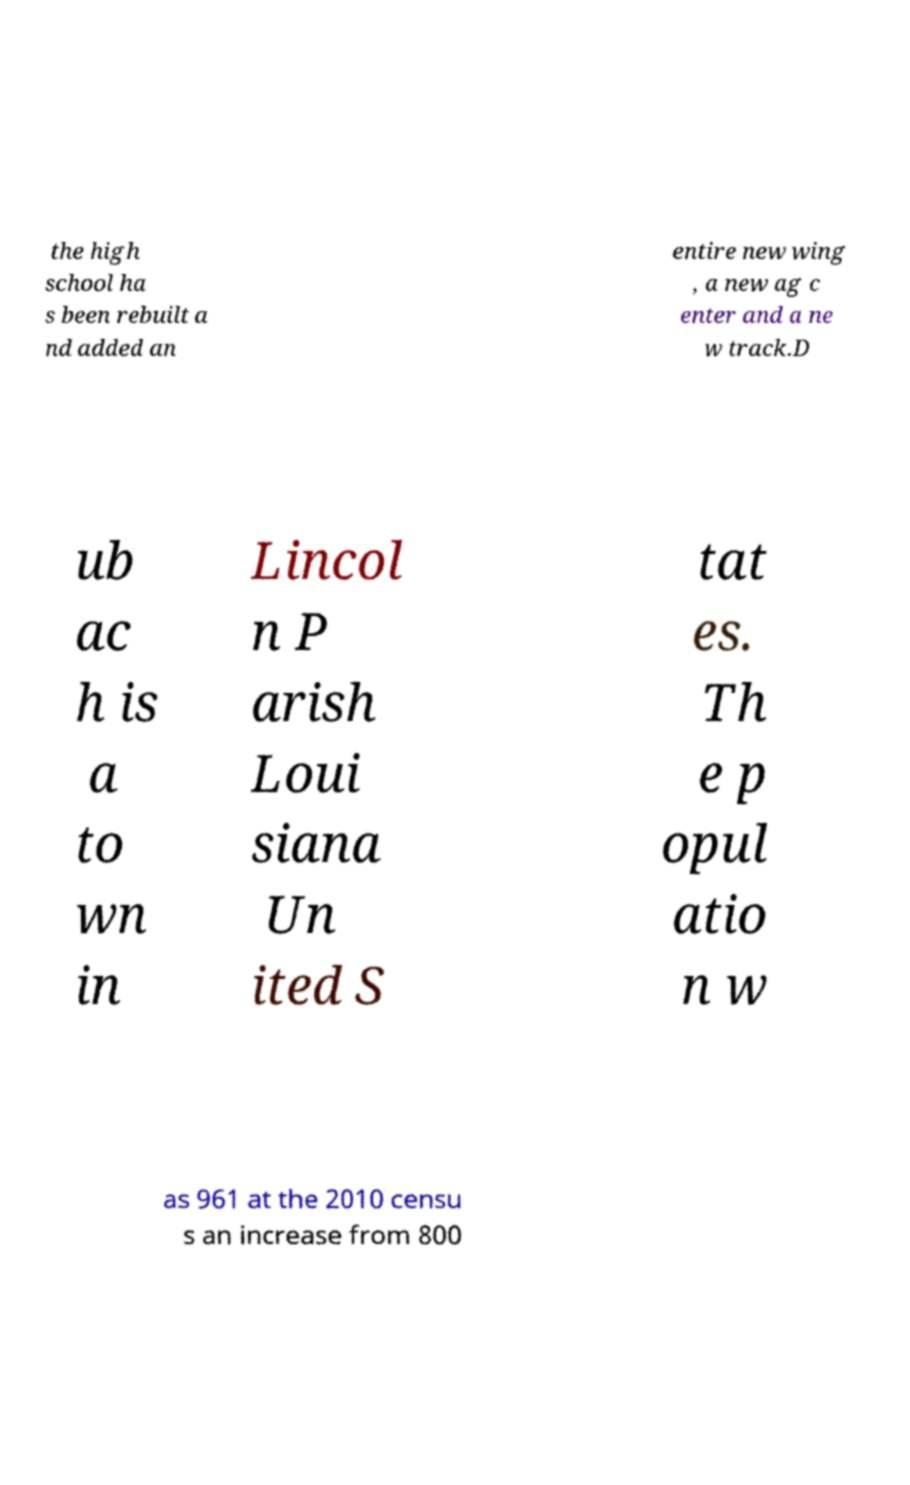What messages or text are displayed in this image? I need them in a readable, typed format. the high school ha s been rebuilt a nd added an entire new wing , a new ag c enter and a ne w track.D ub ac h is a to wn in Lincol n P arish Loui siana Un ited S tat es. Th e p opul atio n w as 961 at the 2010 censu s an increase from 800 